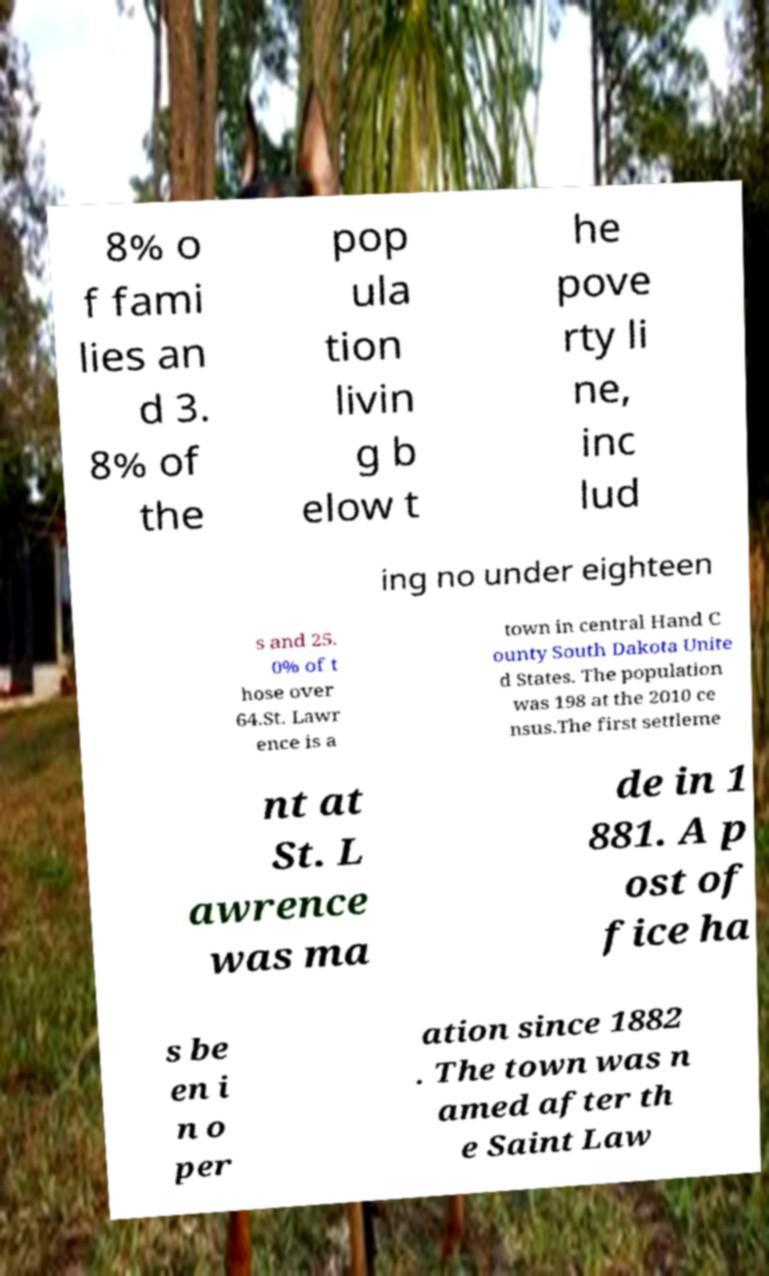Please identify and transcribe the text found in this image. 8% o f fami lies an d 3. 8% of the pop ula tion livin g b elow t he pove rty li ne, inc lud ing no under eighteen s and 25. 0% of t hose over 64.St. Lawr ence is a town in central Hand C ounty South Dakota Unite d States. The population was 198 at the 2010 ce nsus.The first settleme nt at St. L awrence was ma de in 1 881. A p ost of fice ha s be en i n o per ation since 1882 . The town was n amed after th e Saint Law 